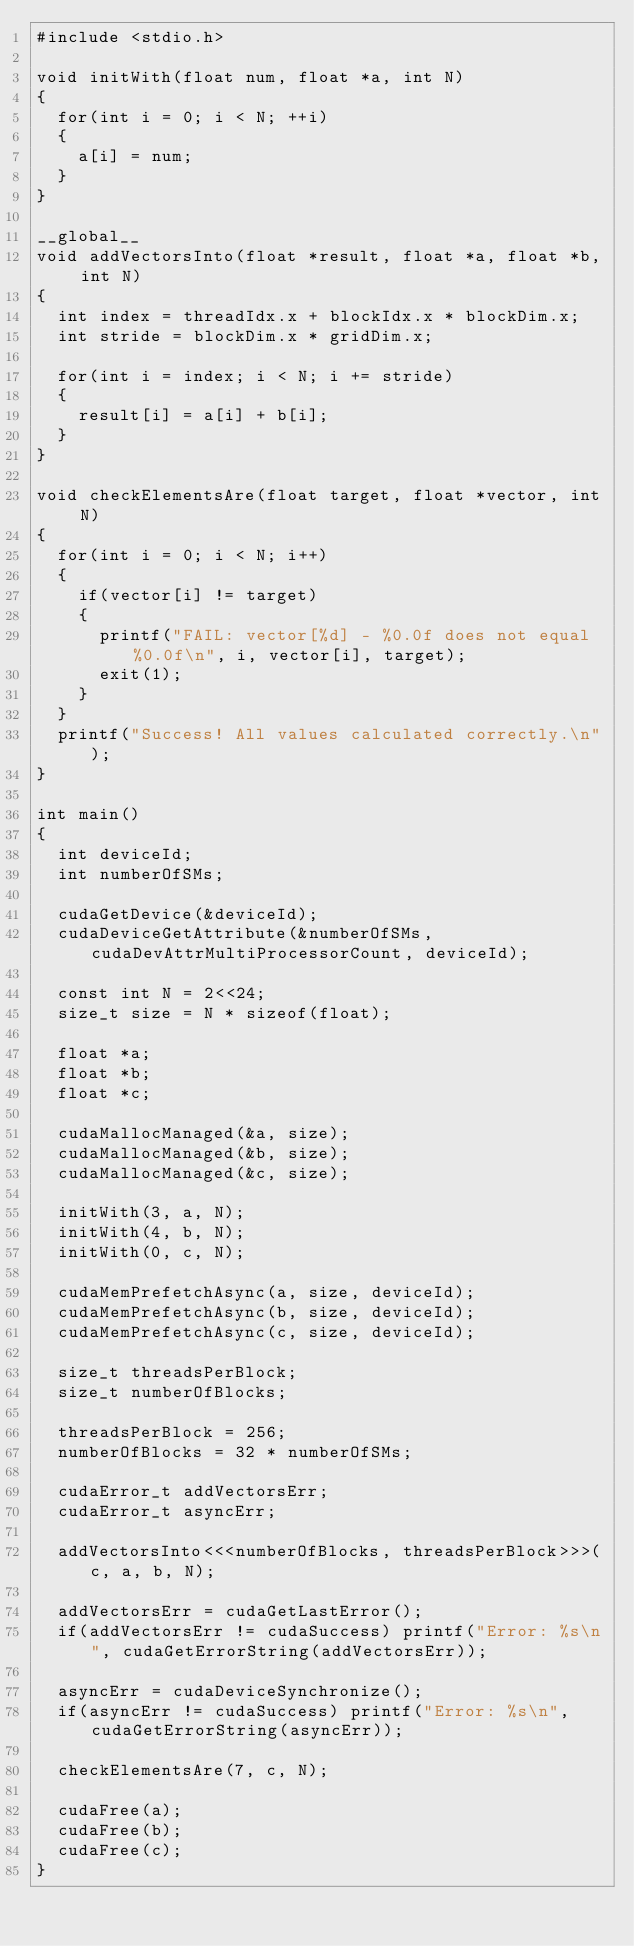<code> <loc_0><loc_0><loc_500><loc_500><_Cuda_>#include <stdio.h>

void initWith(float num, float *a, int N)
{
  for(int i = 0; i < N; ++i)
  {
    a[i] = num;
  }
}

__global__
void addVectorsInto(float *result, float *a, float *b, int N)
{
  int index = threadIdx.x + blockIdx.x * blockDim.x;
  int stride = blockDim.x * gridDim.x;

  for(int i = index; i < N; i += stride)
  {
    result[i] = a[i] + b[i];
  }
}

void checkElementsAre(float target, float *vector, int N)
{
  for(int i = 0; i < N; i++)
  {
    if(vector[i] != target)
    {
      printf("FAIL: vector[%d] - %0.0f does not equal %0.0f\n", i, vector[i], target);
      exit(1);
    }
  }
  printf("Success! All values calculated correctly.\n");
}

int main()
{
  int deviceId;
  int numberOfSMs;

  cudaGetDevice(&deviceId);
  cudaDeviceGetAttribute(&numberOfSMs, cudaDevAttrMultiProcessorCount, deviceId);

  const int N = 2<<24;
  size_t size = N * sizeof(float);

  float *a;
  float *b;
  float *c;

  cudaMallocManaged(&a, size);
  cudaMallocManaged(&b, size);
  cudaMallocManaged(&c, size);

  initWith(3, a, N);
  initWith(4, b, N);
  initWith(0, c, N);

  cudaMemPrefetchAsync(a, size, deviceId);
  cudaMemPrefetchAsync(b, size, deviceId);
  cudaMemPrefetchAsync(c, size, deviceId);

  size_t threadsPerBlock;
  size_t numberOfBlocks;

  threadsPerBlock = 256;
  numberOfBlocks = 32 * numberOfSMs;

  cudaError_t addVectorsErr;
  cudaError_t asyncErr;

  addVectorsInto<<<numberOfBlocks, threadsPerBlock>>>(c, a, b, N);

  addVectorsErr = cudaGetLastError();
  if(addVectorsErr != cudaSuccess) printf("Error: %s\n", cudaGetErrorString(addVectorsErr));

  asyncErr = cudaDeviceSynchronize();
  if(asyncErr != cudaSuccess) printf("Error: %s\n", cudaGetErrorString(asyncErr));

  checkElementsAre(7, c, N);

  cudaFree(a);
  cudaFree(b);
  cudaFree(c);
}
</code> 